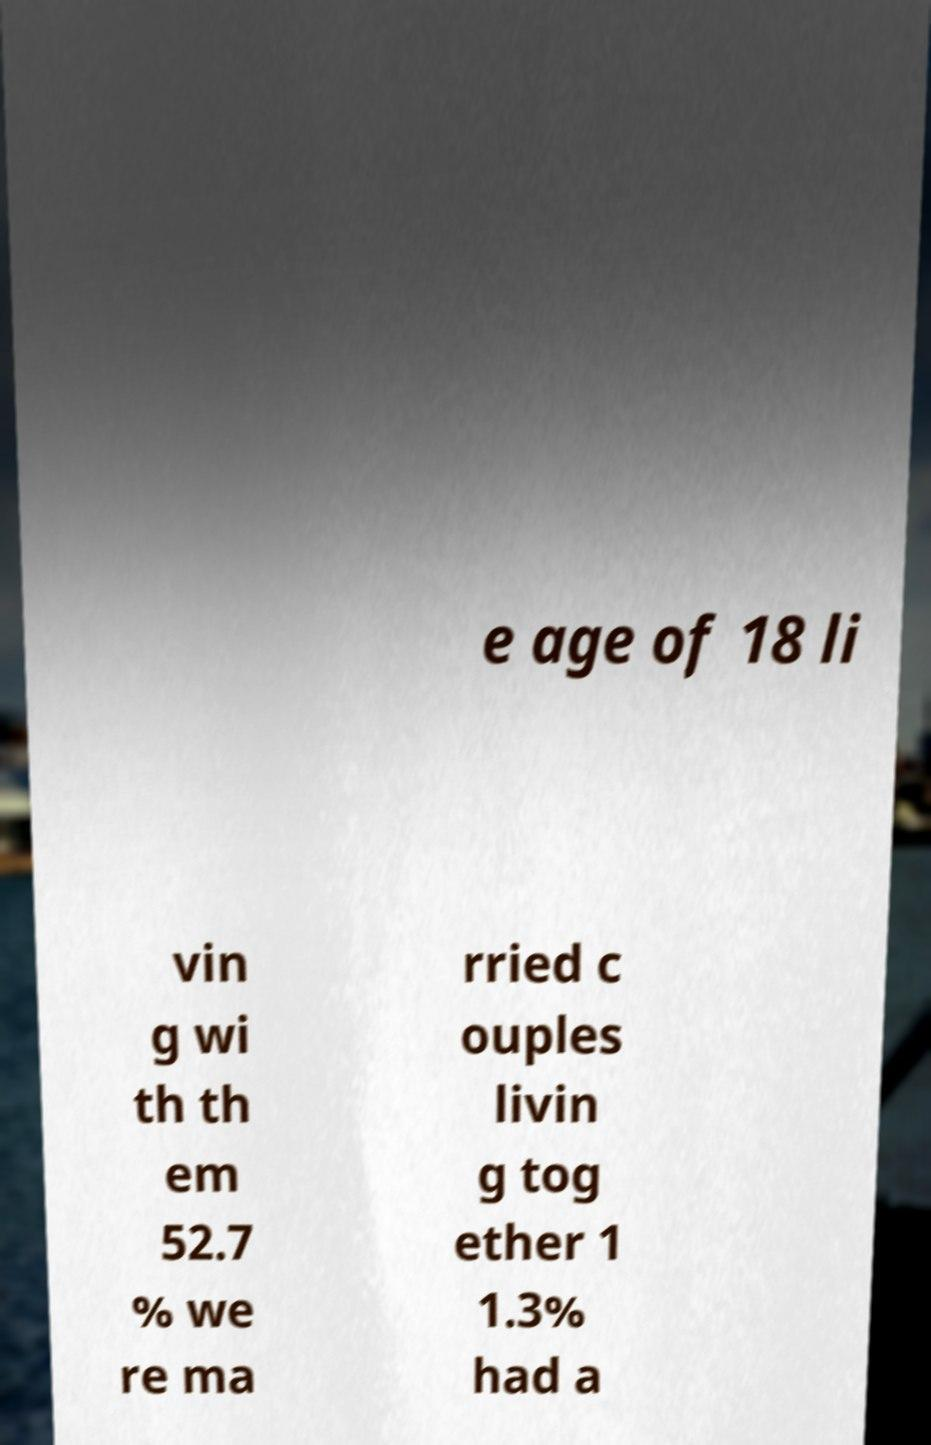I need the written content from this picture converted into text. Can you do that? e age of 18 li vin g wi th th em 52.7 % we re ma rried c ouples livin g tog ether 1 1.3% had a 